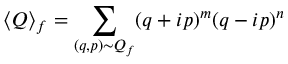<formula> <loc_0><loc_0><loc_500><loc_500>\langle Q \rangle _ { f } = \sum _ { ( q , p ) \sim Q _ { f } } ( q + i p ) ^ { m } ( q - i p ) ^ { n }</formula> 